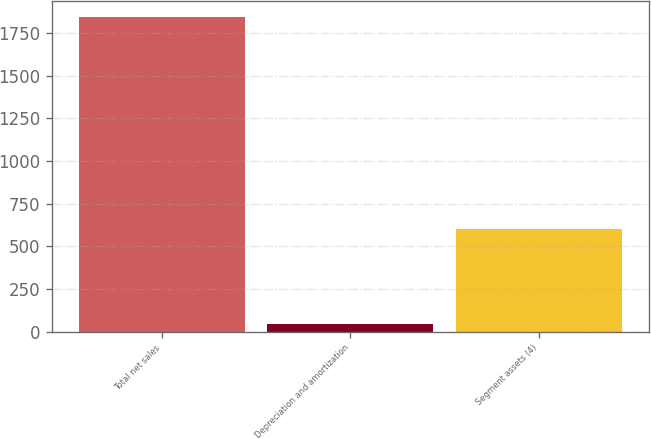Convert chart. <chart><loc_0><loc_0><loc_500><loc_500><bar_chart><fcel>Total net sales<fcel>Depreciation and amortization<fcel>Segment assets (4)<nl><fcel>1845<fcel>44<fcel>603<nl></chart> 